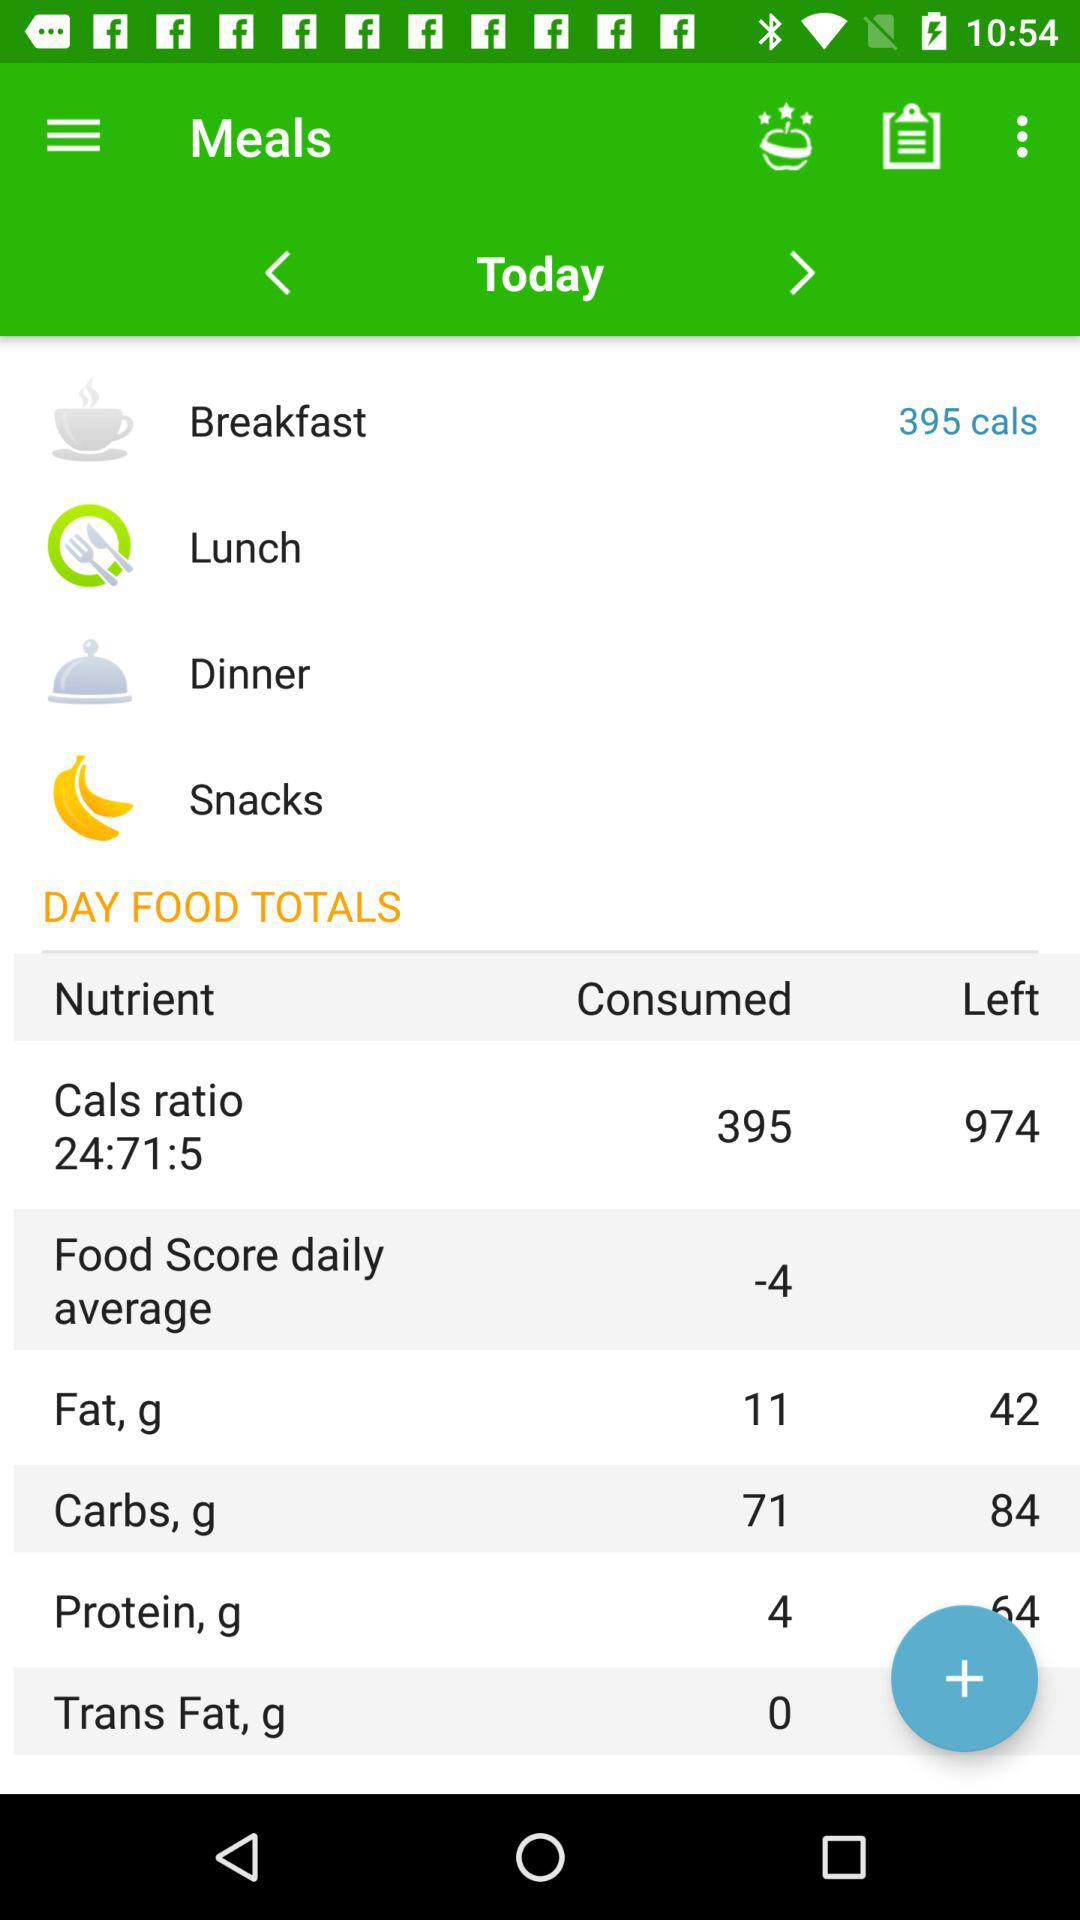How many calories are left?
Answer the question using a single word or phrase. 974 